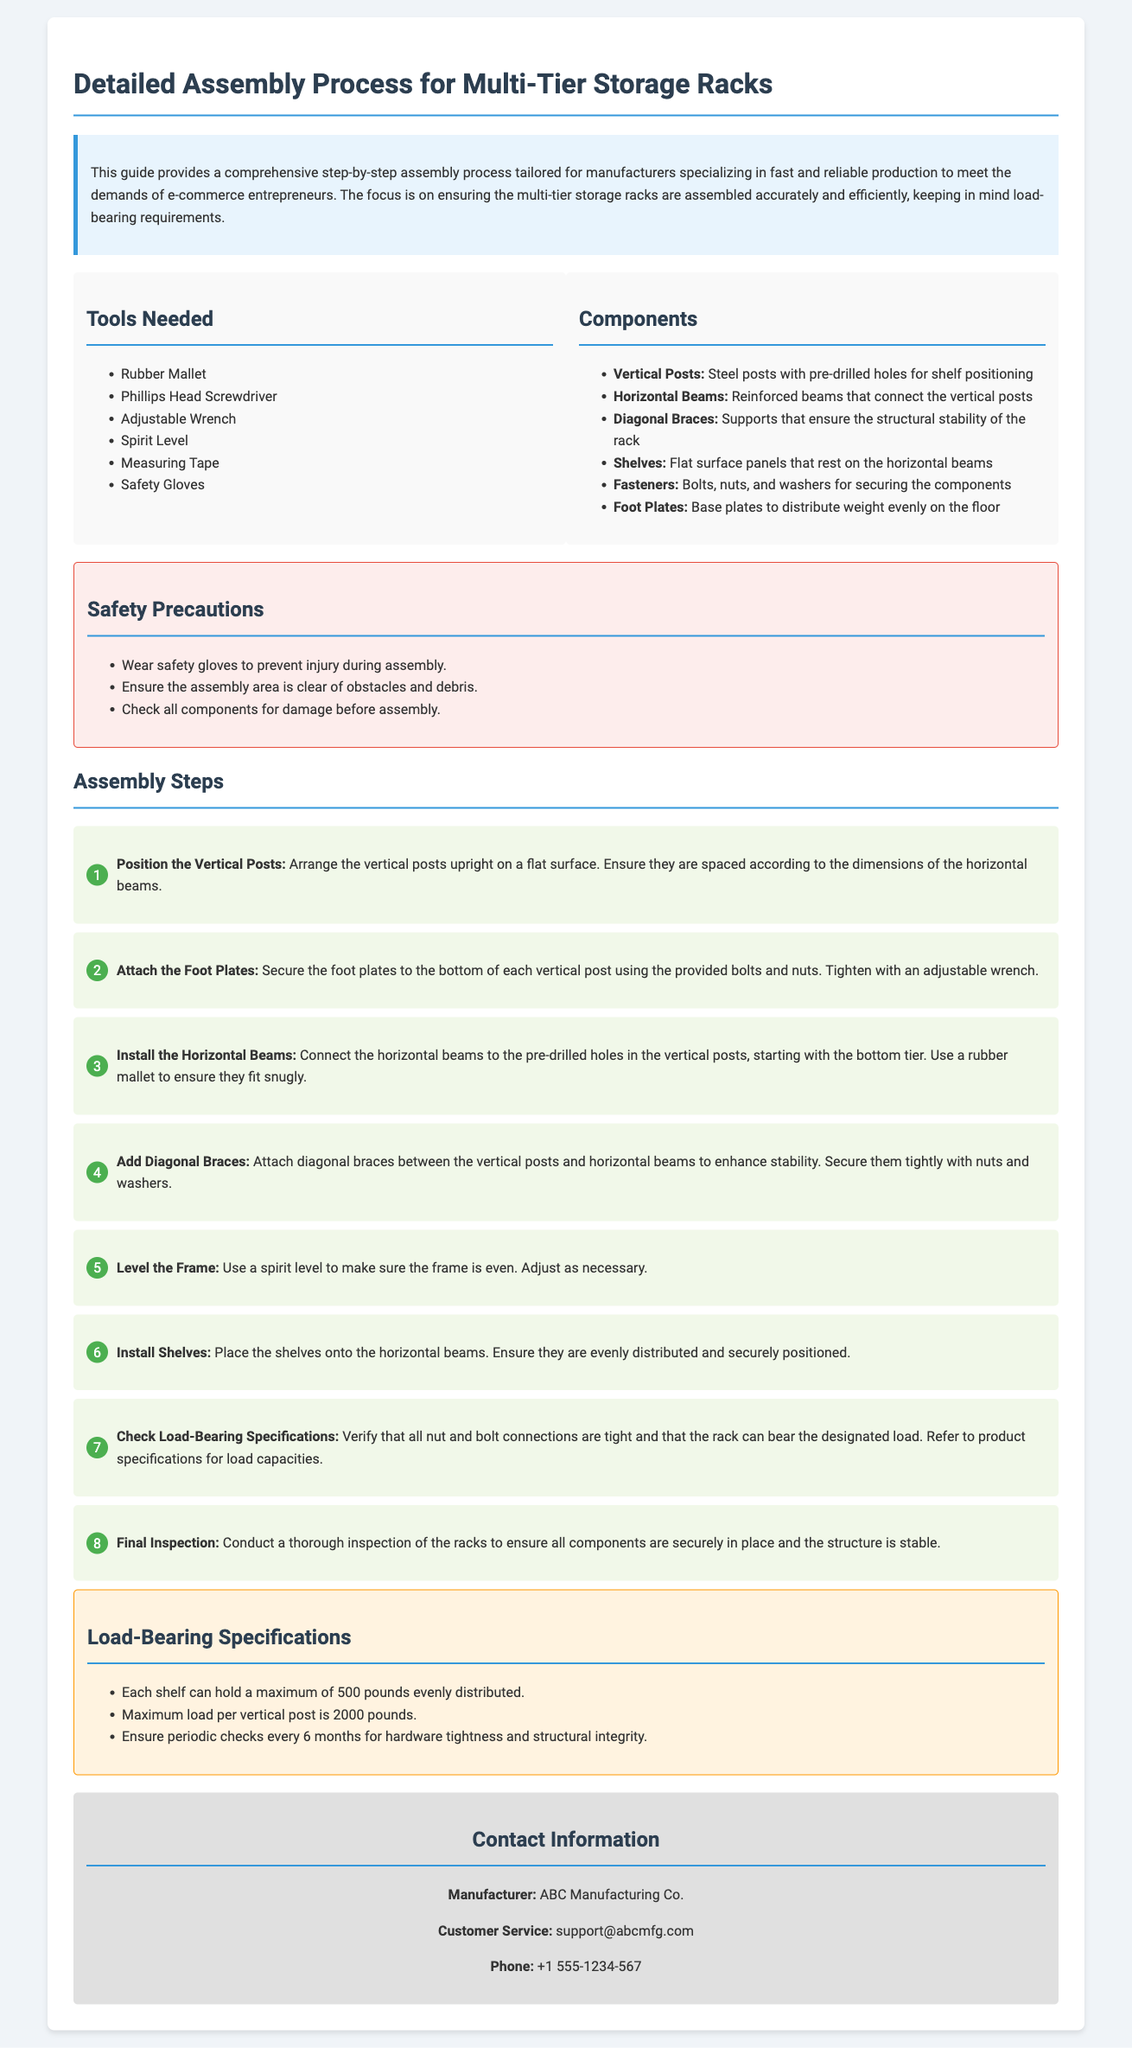What tools are needed for assembly? The document lists the tools required for assembly, which include a rubber mallet, screwdriver, adjustable wrench, spirit level, measuring tape, and safety gloves.
Answer: Rubber Mallet, Phillips Head Screwdriver, Adjustable Wrench, Spirit Level, Measuring Tape, Safety Gloves What is the maximum load per vertical post? The document specifies the load-bearing specifications, stating that the maximum load per vertical post is 2000 pounds.
Answer: 2000 pounds What is the first step in the assembly process? The assembly steps provide a sequence of actions, with the first step being to position the vertical posts.
Answer: Position the Vertical Posts How many pounds can each shelf hold? According to the load-bearing specifications, each shelf is capable of holding up to 500 pounds evenly distributed.
Answer: 500 pounds What should be checked every six months? The document mentions that periodic checks for hardware tightness and structural integrity should be conducted every six months.
Answer: Hardware tightness and structural integrity What are diagonal braces used for? The assembly instructions indicate that diagonal braces are used to ensure the structural stability of the rack.
Answer: Structural stability What type of document is this? The content revolves around assembly instructions for a specific product, guiding users through the assembly process and safety measures.
Answer: Assembly instructions What component connects the vertical posts? The components section outlines that horizontal beams connect the vertical posts during the assembly.
Answer: Horizontal Beams 